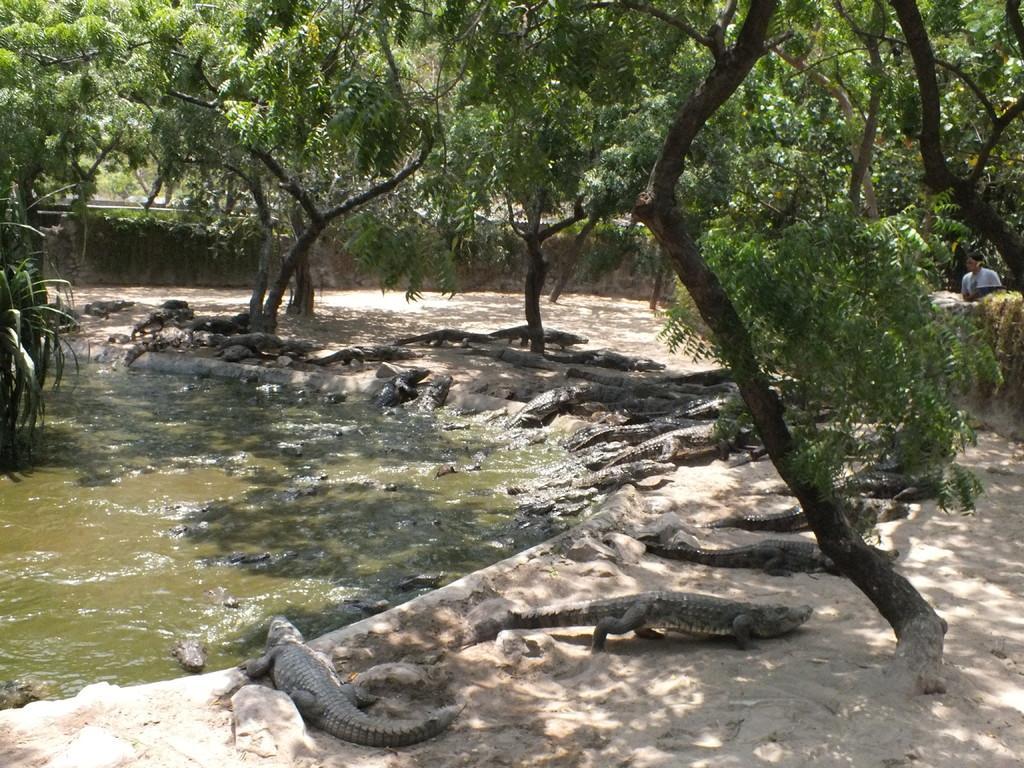Please provide a concise description of this image. In this image I can see few crocodiles on the ground and few are in the water. I can see few trees which are green and brown in color and a person standing. In the background I can see the wall and few trees. 